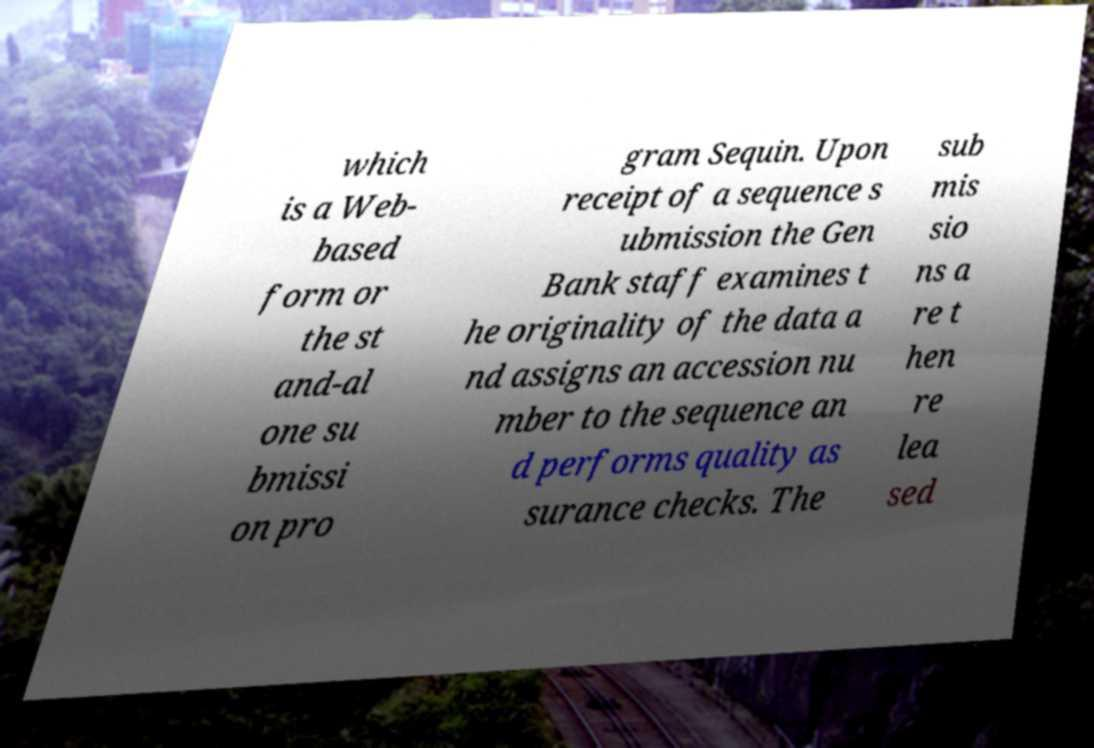For documentation purposes, I need the text within this image transcribed. Could you provide that? which is a Web- based form or the st and-al one su bmissi on pro gram Sequin. Upon receipt of a sequence s ubmission the Gen Bank staff examines t he originality of the data a nd assigns an accession nu mber to the sequence an d performs quality as surance checks. The sub mis sio ns a re t hen re lea sed 